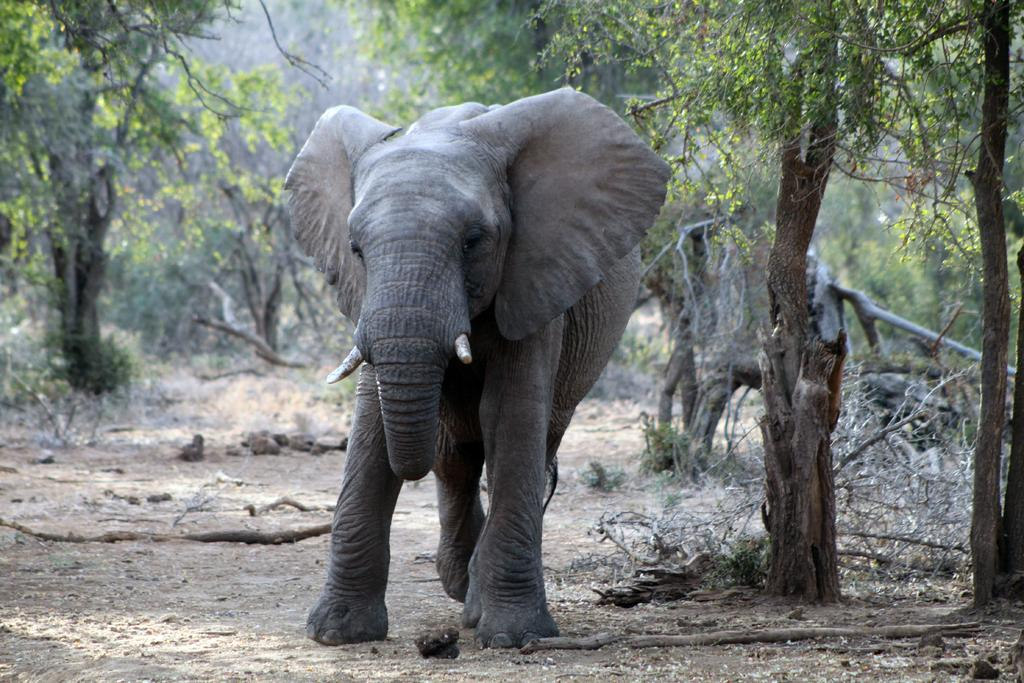What is the main subject in the front of the image? There is an elephant in the front of the image. What can be seen in the background of the image? There are trees, branches, and rocks in the background of the image. What type of mine is visible in the image? There is no mine present in the image. What idea does the elephant have in the image? Elephants do not have ideas, as they are animals and not capable of human thought processes. 